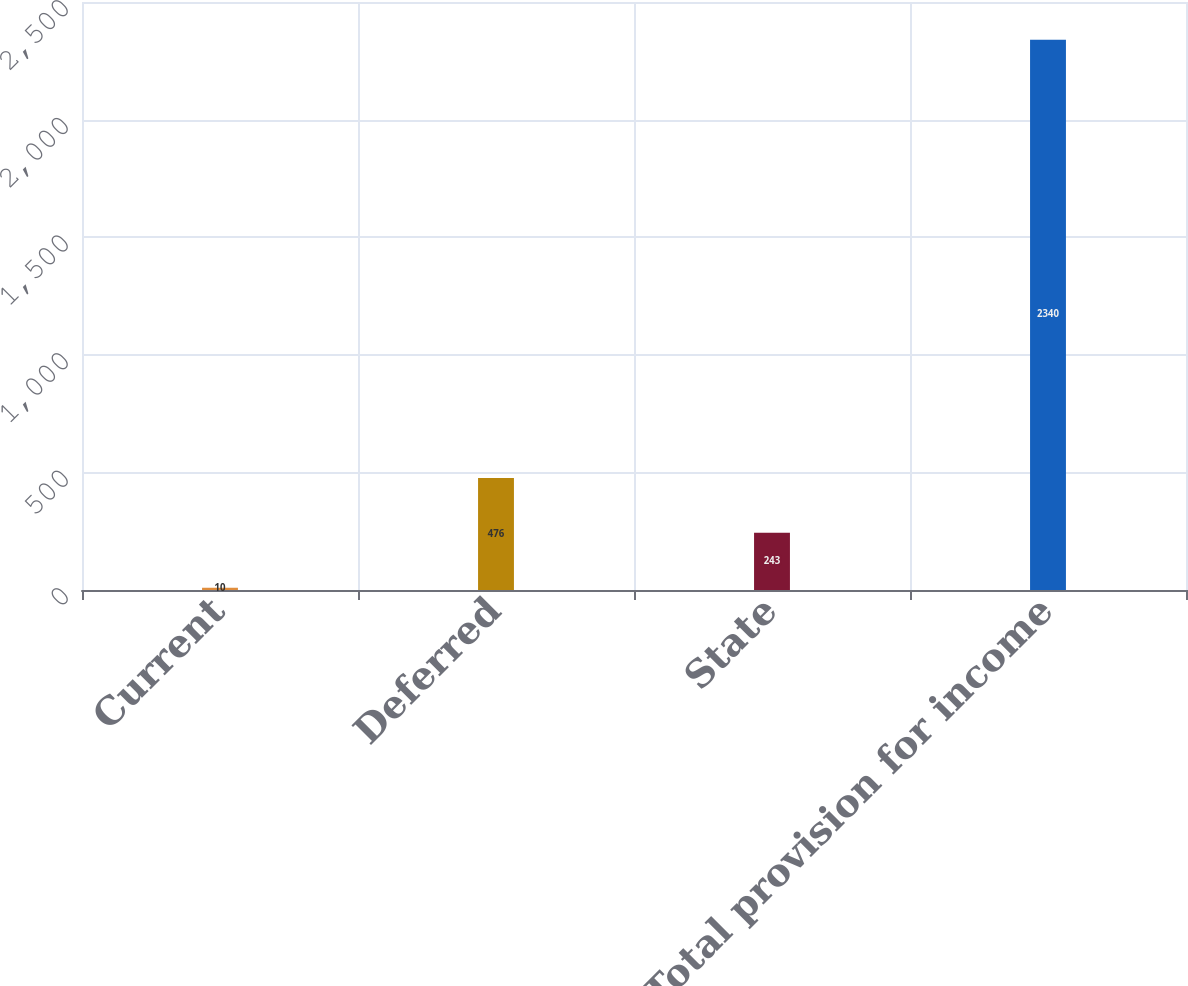Convert chart to OTSL. <chart><loc_0><loc_0><loc_500><loc_500><bar_chart><fcel>Current<fcel>Deferred<fcel>State<fcel>Total provision for income<nl><fcel>10<fcel>476<fcel>243<fcel>2340<nl></chart> 